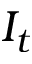<formula> <loc_0><loc_0><loc_500><loc_500>I _ { t }</formula> 